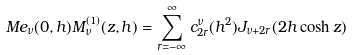Convert formula to latex. <formula><loc_0><loc_0><loc_500><loc_500>M e _ { \nu } ( 0 , h ) M ^ { ( 1 ) } _ { \nu } ( z , h ) = \sum ^ { \infty } _ { r = - \infty } c ^ { \nu } _ { 2 r } ( h ^ { 2 } ) J _ { \nu + 2 r } ( 2 h \cosh z )</formula> 